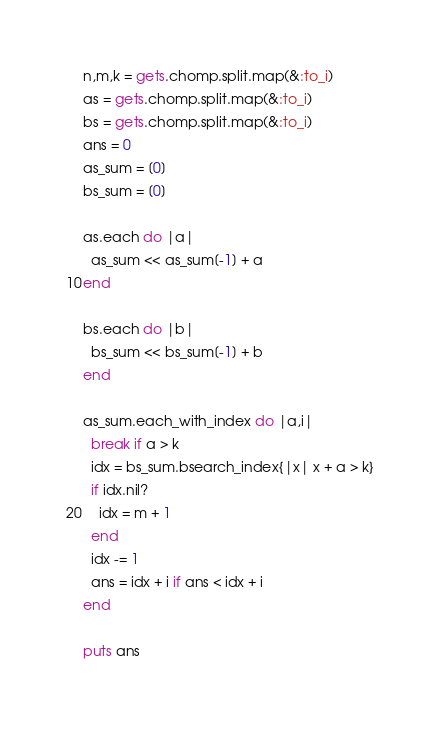<code> <loc_0><loc_0><loc_500><loc_500><_Ruby_>n,m,k = gets.chomp.split.map(&:to_i)
as = gets.chomp.split.map(&:to_i)
bs = gets.chomp.split.map(&:to_i)
ans = 0
as_sum = [0]
bs_sum = [0]

as.each do |a|
  as_sum << as_sum[-1] + a
end

bs.each do |b|
  bs_sum << bs_sum[-1] + b
end

as_sum.each_with_index do |a,i|
  break if a > k
  idx = bs_sum.bsearch_index{|x| x + a > k}
  if idx.nil?
    idx = m + 1
  end
  idx -= 1
  ans = idx + i if ans < idx + i
end

puts ans
</code> 